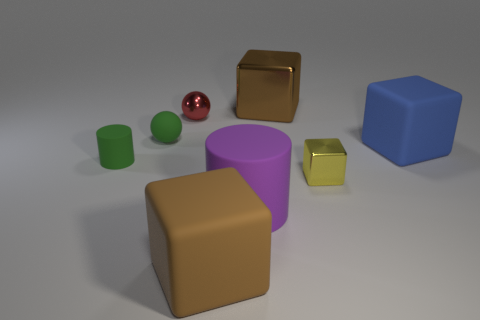Add 2 big blue matte objects. How many objects exist? 10 Subtract all cylinders. How many objects are left? 6 Add 7 tiny green matte cylinders. How many tiny green matte cylinders are left? 8 Add 6 tiny green balls. How many tiny green balls exist? 7 Subtract 1 green spheres. How many objects are left? 7 Subtract all large green cylinders. Subtract all small shiny blocks. How many objects are left? 7 